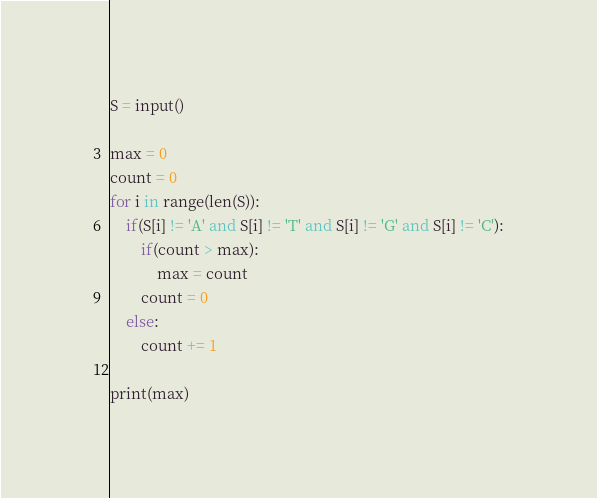<code> <loc_0><loc_0><loc_500><loc_500><_Python_>S = input()

max = 0
count = 0
for i in range(len(S)):
    if(S[i] != 'A' and S[i] != 'T' and S[i] != 'G' and S[i] != 'C'):
        if(count > max):
            max = count
        count = 0
    else:
        count += 1

print(max)</code> 